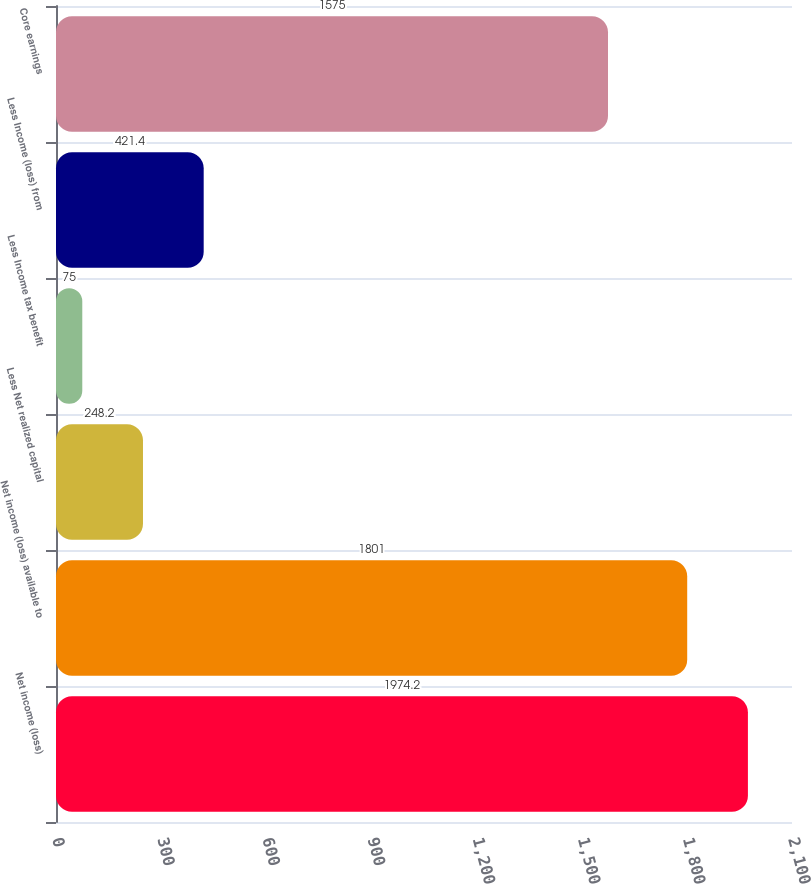<chart> <loc_0><loc_0><loc_500><loc_500><bar_chart><fcel>Net income (loss)<fcel>Net income (loss) available to<fcel>Less Net realized capital<fcel>Less Income tax benefit<fcel>Less Income (loss) from<fcel>Core earnings<nl><fcel>1974.2<fcel>1801<fcel>248.2<fcel>75<fcel>421.4<fcel>1575<nl></chart> 